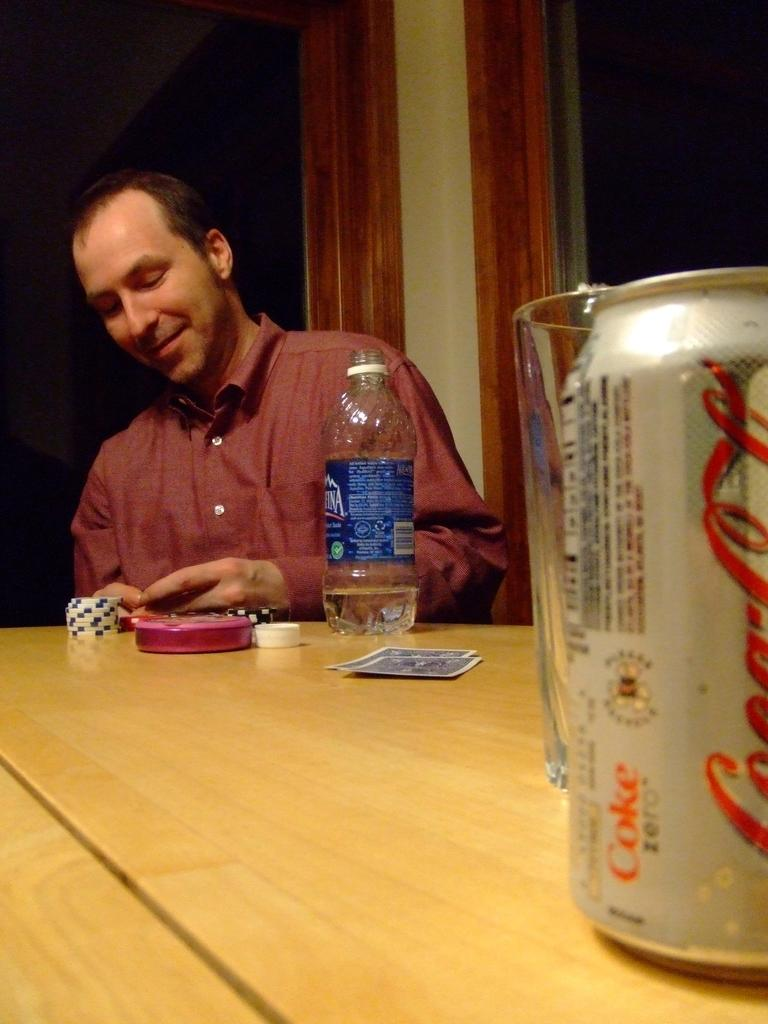Provide a one-sentence caption for the provided image. Man is gambling while having a can of Coca Cola and a bottle of Aquafina Water. 